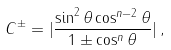Convert formula to latex. <formula><loc_0><loc_0><loc_500><loc_500>C ^ { \pm } = | \frac { \sin ^ { 2 } \theta \cos ^ { n - 2 } \theta } { 1 \pm \cos ^ { n } \theta } | \, ,</formula> 